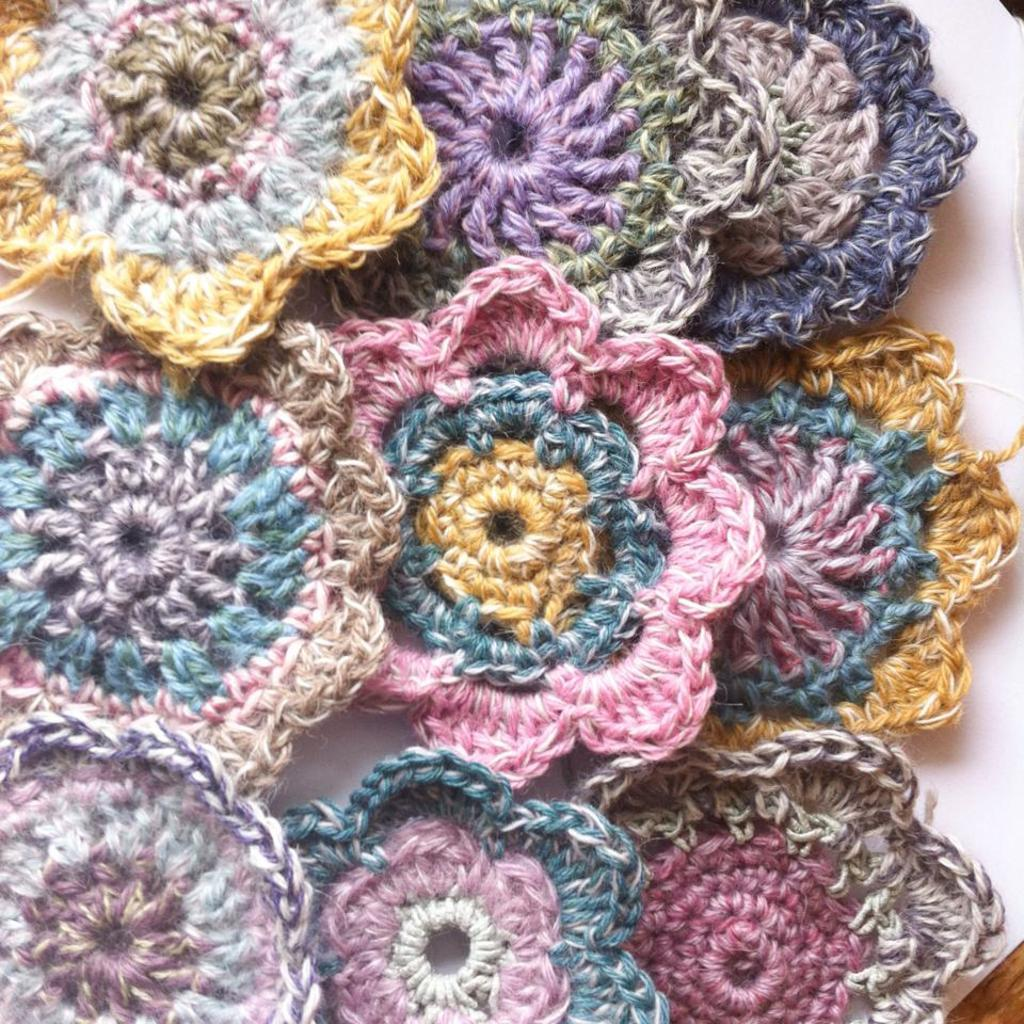What type of material is featured in the image? There is woolen crochet in the image. Can you describe the texture of the material? The woolen crochet has a soft and textured appearance. What might the woolen crochet be used for? The woolen crochet could be used for various purposes, such as making clothing, accessories, or decorative items. How many waves can be seen crashing on the shore in the image? There are no waves present in the image; it features woolen crochet. 